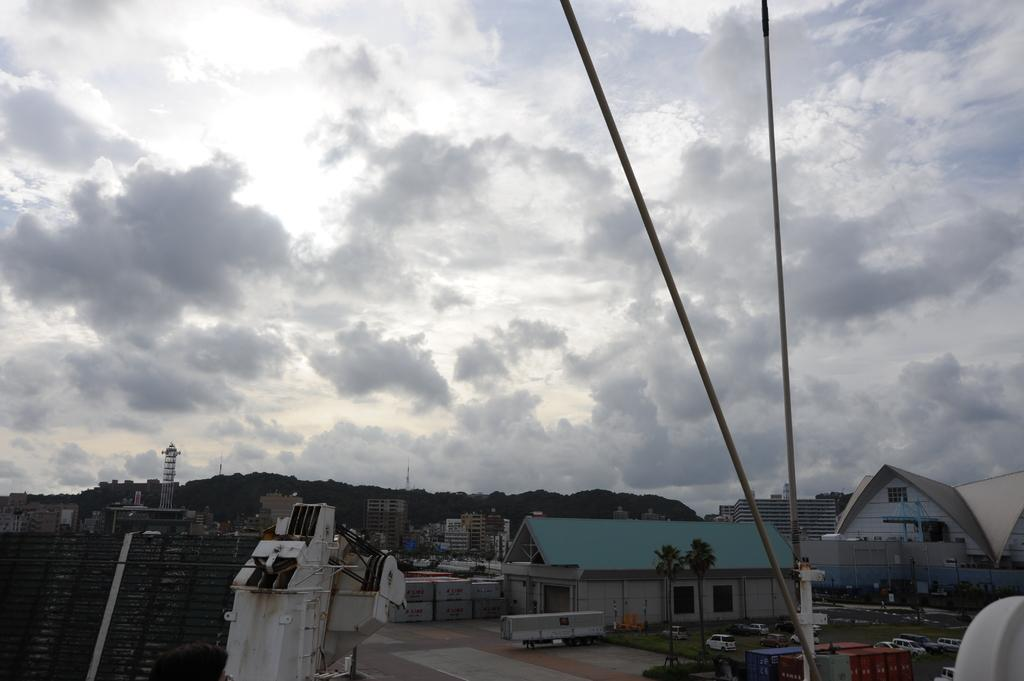What type of structures can be seen in the image? There are buildings, sheds, and towers in the image. What natural elements are present in the image? There are trees in the image. What man-made objects can be seen in the image? Motor vehicles and poles are visible in the image. What is visible in the sky in the image? The sky is visible in the image, and clouds are present. How many types of structures are present in the image? There are three types of structures: buildings, sheds, and towers. What color is the cherry on top of the tower in the image? There is no cherry present on top of any tower in the image. How does the ball move around in the image? There is no ball present in the image; it is not possible to answer this question. 